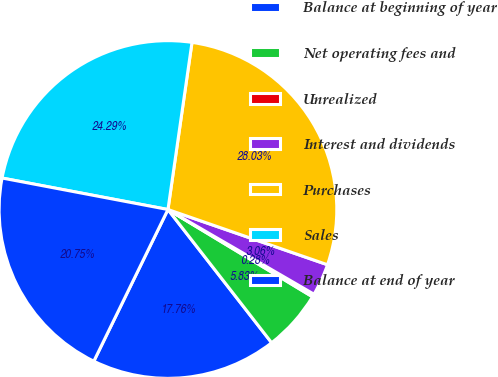<chart> <loc_0><loc_0><loc_500><loc_500><pie_chart><fcel>Balance at beginning of year<fcel>Net operating fees and<fcel>Unrealized<fcel>Interest and dividends<fcel>Purchases<fcel>Sales<fcel>Balance at end of year<nl><fcel>17.76%<fcel>5.83%<fcel>0.28%<fcel>3.06%<fcel>28.03%<fcel>24.29%<fcel>20.75%<nl></chart> 